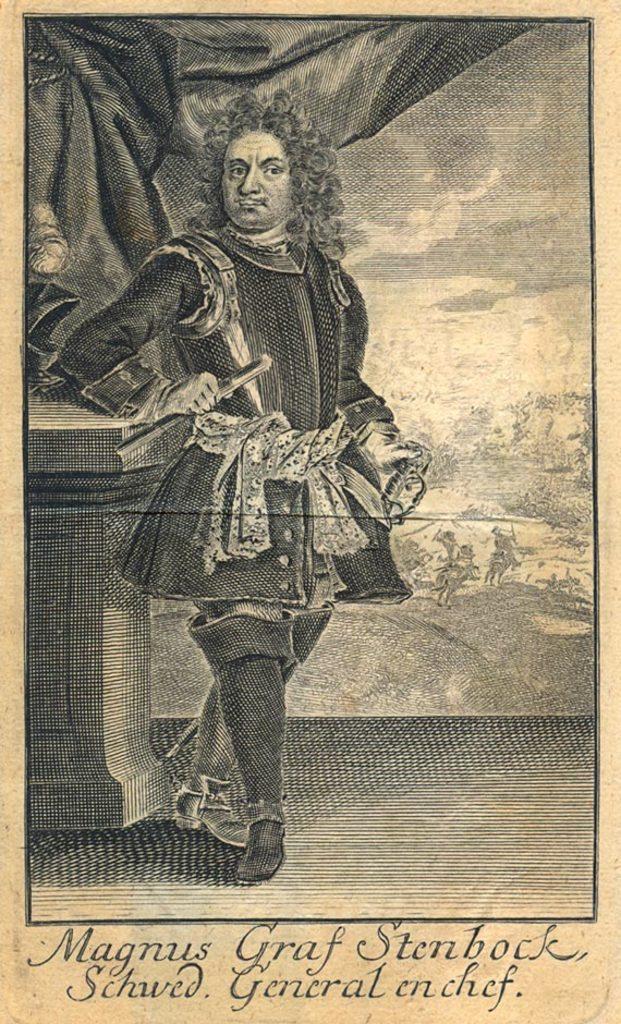How would you summarize this image in a sentence or two? As we can see in the image there is a paper. On paper there is a black color dress. 